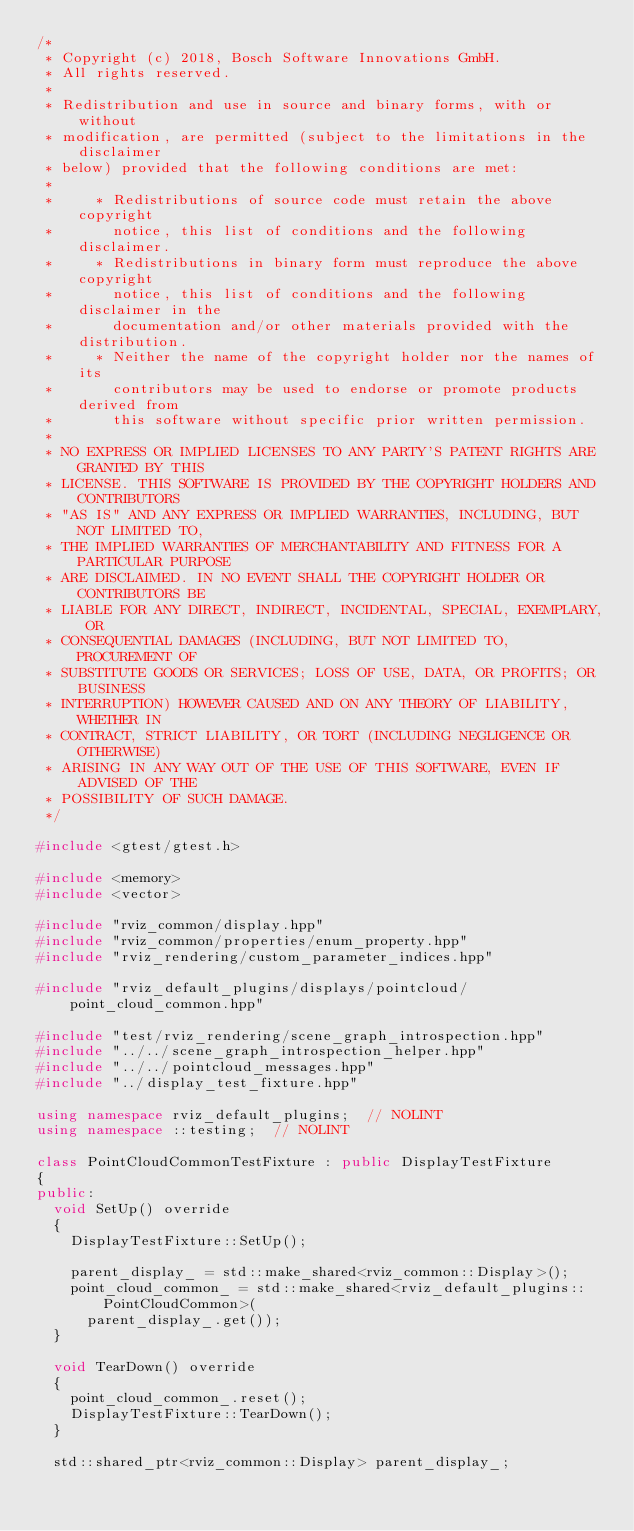<code> <loc_0><loc_0><loc_500><loc_500><_C++_>/*
 * Copyright (c) 2018, Bosch Software Innovations GmbH.
 * All rights reserved.
 *
 * Redistribution and use in source and binary forms, with or without
 * modification, are permitted (subject to the limitations in the disclaimer
 * below) provided that the following conditions are met:
 *
 *     * Redistributions of source code must retain the above copyright
 *       notice, this list of conditions and the following disclaimer.
 *     * Redistributions in binary form must reproduce the above copyright
 *       notice, this list of conditions and the following disclaimer in the
 *       documentation and/or other materials provided with the distribution.
 *     * Neither the name of the copyright holder nor the names of its
 *       contributors may be used to endorse or promote products derived from
 *       this software without specific prior written permission.
 *
 * NO EXPRESS OR IMPLIED LICENSES TO ANY PARTY'S PATENT RIGHTS ARE GRANTED BY THIS
 * LICENSE. THIS SOFTWARE IS PROVIDED BY THE COPYRIGHT HOLDERS AND CONTRIBUTORS
 * "AS IS" AND ANY EXPRESS OR IMPLIED WARRANTIES, INCLUDING, BUT NOT LIMITED TO,
 * THE IMPLIED WARRANTIES OF MERCHANTABILITY AND FITNESS FOR A PARTICULAR PURPOSE
 * ARE DISCLAIMED. IN NO EVENT SHALL THE COPYRIGHT HOLDER OR CONTRIBUTORS BE
 * LIABLE FOR ANY DIRECT, INDIRECT, INCIDENTAL, SPECIAL, EXEMPLARY, OR
 * CONSEQUENTIAL DAMAGES (INCLUDING, BUT NOT LIMITED TO, PROCUREMENT OF
 * SUBSTITUTE GOODS OR SERVICES; LOSS OF USE, DATA, OR PROFITS; OR BUSINESS
 * INTERRUPTION) HOWEVER CAUSED AND ON ANY THEORY OF LIABILITY, WHETHER IN
 * CONTRACT, STRICT LIABILITY, OR TORT (INCLUDING NEGLIGENCE OR OTHERWISE)
 * ARISING IN ANY WAY OUT OF THE USE OF THIS SOFTWARE, EVEN IF ADVISED OF THE
 * POSSIBILITY OF SUCH DAMAGE.
 */

#include <gtest/gtest.h>

#include <memory>
#include <vector>

#include "rviz_common/display.hpp"
#include "rviz_common/properties/enum_property.hpp"
#include "rviz_rendering/custom_parameter_indices.hpp"

#include "rviz_default_plugins/displays/pointcloud/point_cloud_common.hpp"

#include "test/rviz_rendering/scene_graph_introspection.hpp"
#include "../../scene_graph_introspection_helper.hpp"
#include "../../pointcloud_messages.hpp"
#include "../display_test_fixture.hpp"

using namespace rviz_default_plugins;  // NOLINT
using namespace ::testing;  // NOLINT

class PointCloudCommonTestFixture : public DisplayTestFixture
{
public:
  void SetUp() override
  {
    DisplayTestFixture::SetUp();

    parent_display_ = std::make_shared<rviz_common::Display>();
    point_cloud_common_ = std::make_shared<rviz_default_plugins::PointCloudCommon>(
      parent_display_.get());
  }

  void TearDown() override
  {
    point_cloud_common_.reset();
    DisplayTestFixture::TearDown();
  }

  std::shared_ptr<rviz_common::Display> parent_display_;</code> 